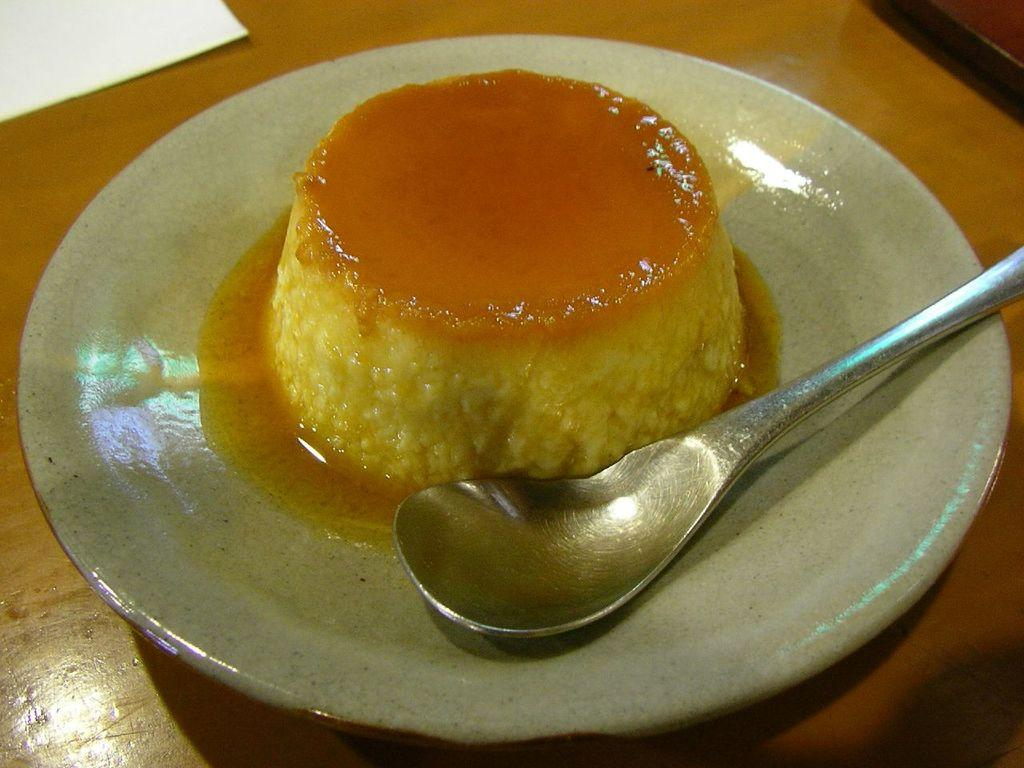What is the main food item visible in the image? There is a pancake in the image. Where is the pancake located? The pancake is in a saucer. What utensil can be seen in the image? There is a spoon in the image. On what surface is the saucer placed? The saucer is on a wooden table. What type of throne is present in the image? There is no throne present in the image. What room is the pancake being served in? The image does not provide information about the room or location where the pancake is being served. 